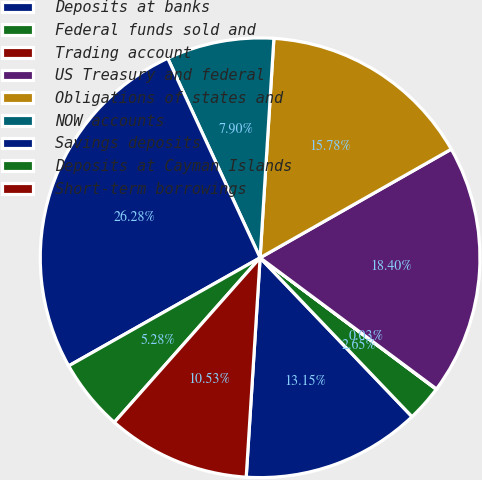Convert chart to OTSL. <chart><loc_0><loc_0><loc_500><loc_500><pie_chart><fcel>Deposits at banks<fcel>Federal funds sold and<fcel>Trading account<fcel>US Treasury and federal<fcel>Obligations of states and<fcel>NOW accounts<fcel>Savings deposits<fcel>Deposits at Cayman Islands<fcel>Short-term borrowings<nl><fcel>13.15%<fcel>2.65%<fcel>0.03%<fcel>18.4%<fcel>15.78%<fcel>7.9%<fcel>26.28%<fcel>5.28%<fcel>10.53%<nl></chart> 